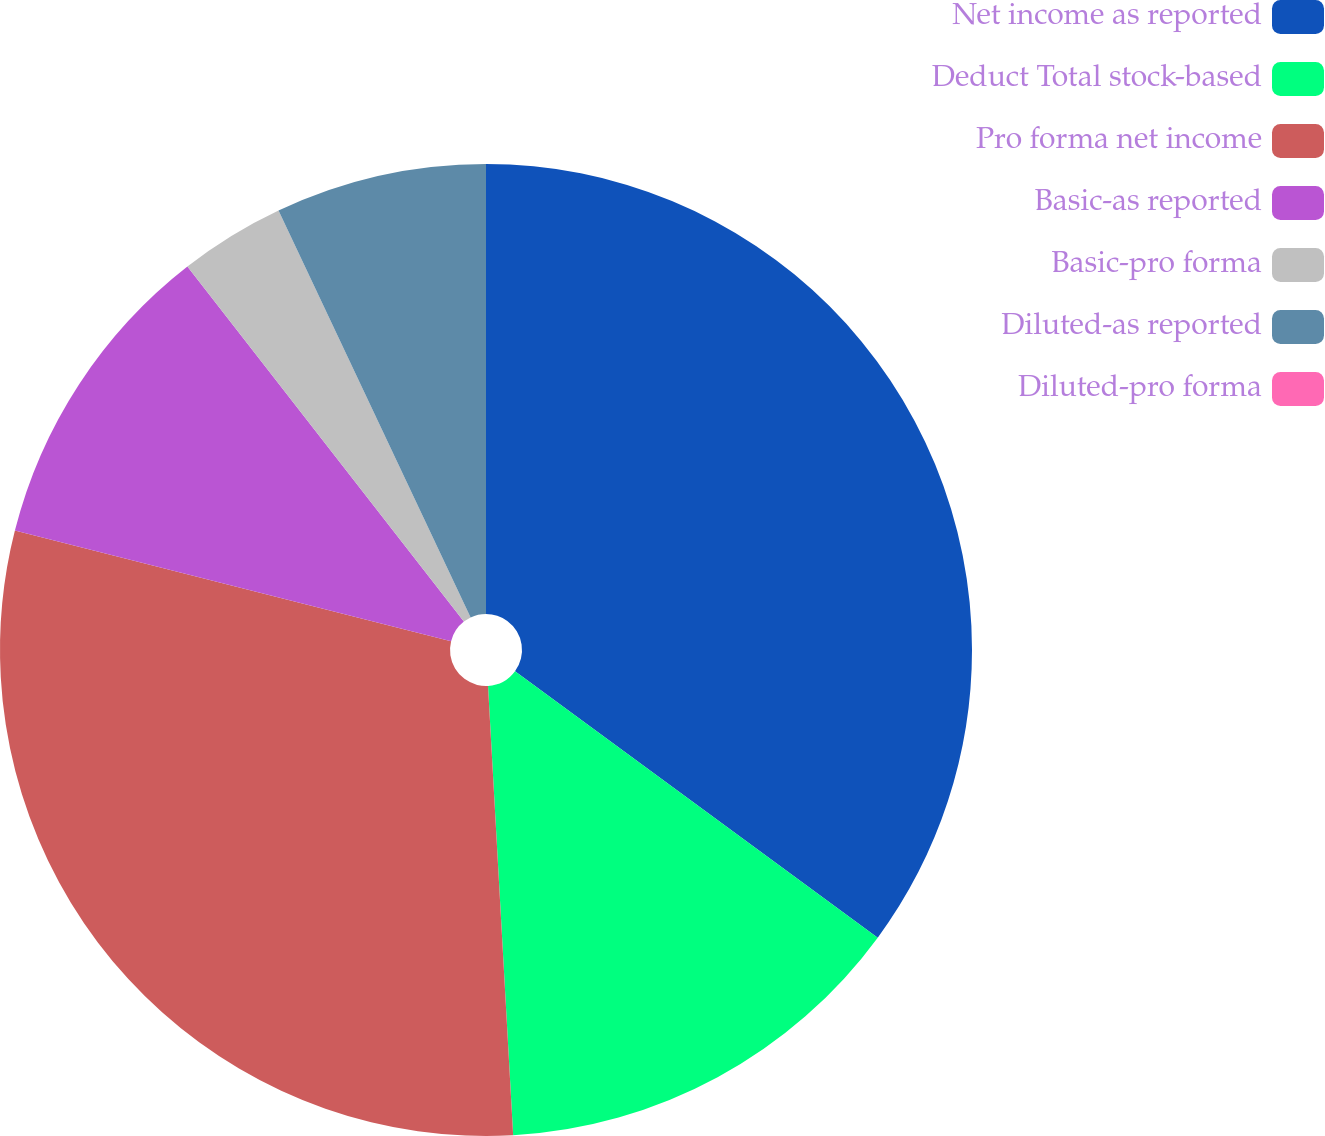Convert chart. <chart><loc_0><loc_0><loc_500><loc_500><pie_chart><fcel>Net income as reported<fcel>Deduct Total stock-based<fcel>Pro forma net income<fcel>Basic-as reported<fcel>Basic-pro forma<fcel>Diluted-as reported<fcel>Diluted-pro forma<nl><fcel>35.08%<fcel>14.03%<fcel>29.84%<fcel>10.52%<fcel>3.51%<fcel>7.02%<fcel>0.0%<nl></chart> 